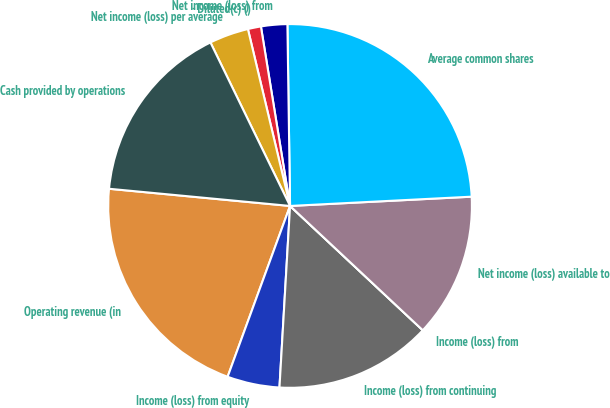Convert chart. <chart><loc_0><loc_0><loc_500><loc_500><pie_chart><fcel>Operating revenue (in<fcel>Income (loss) from equity<fcel>Income (loss) from continuing<fcel>Income (loss) from<fcel>Net income (loss) available to<fcel>Average common shares<fcel>Net income (loss) from<fcel>- Diluted(c) ()<fcel>Net income (loss) per average<fcel>Cash provided by operations<nl><fcel>20.93%<fcel>4.65%<fcel>13.95%<fcel>0.0%<fcel>12.79%<fcel>24.42%<fcel>2.33%<fcel>1.16%<fcel>3.49%<fcel>16.28%<nl></chart> 